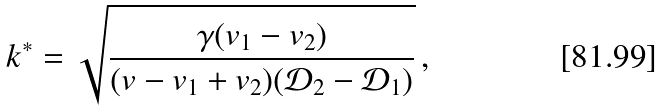Convert formula to latex. <formula><loc_0><loc_0><loc_500><loc_500>k ^ { * } = \sqrt { \frac { \gamma ( { v } _ { 1 } - { v } _ { 2 } ) } { ( v - { v } _ { 1 } + { v } _ { 2 } ) ( { \mathcal { D } } _ { 2 } - { \mathcal { D } } _ { 1 } ) } } \, ,</formula> 